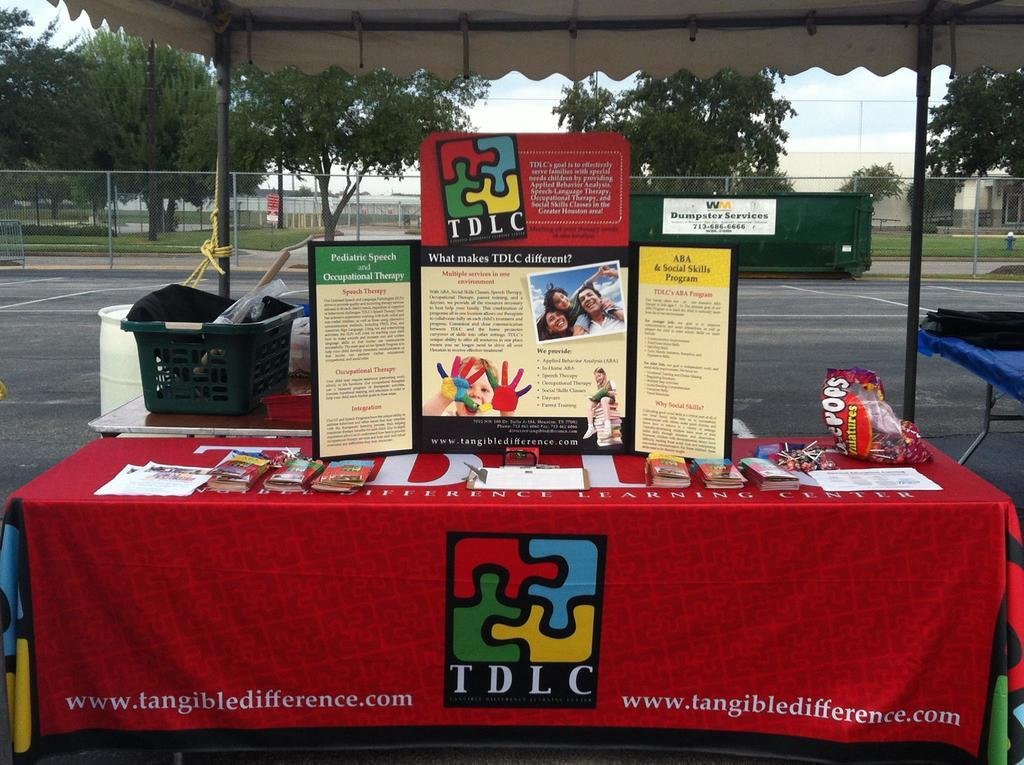<image>
Provide a brief description of the given image. An informational booth set up for TDLC, tangibledifference.com. 